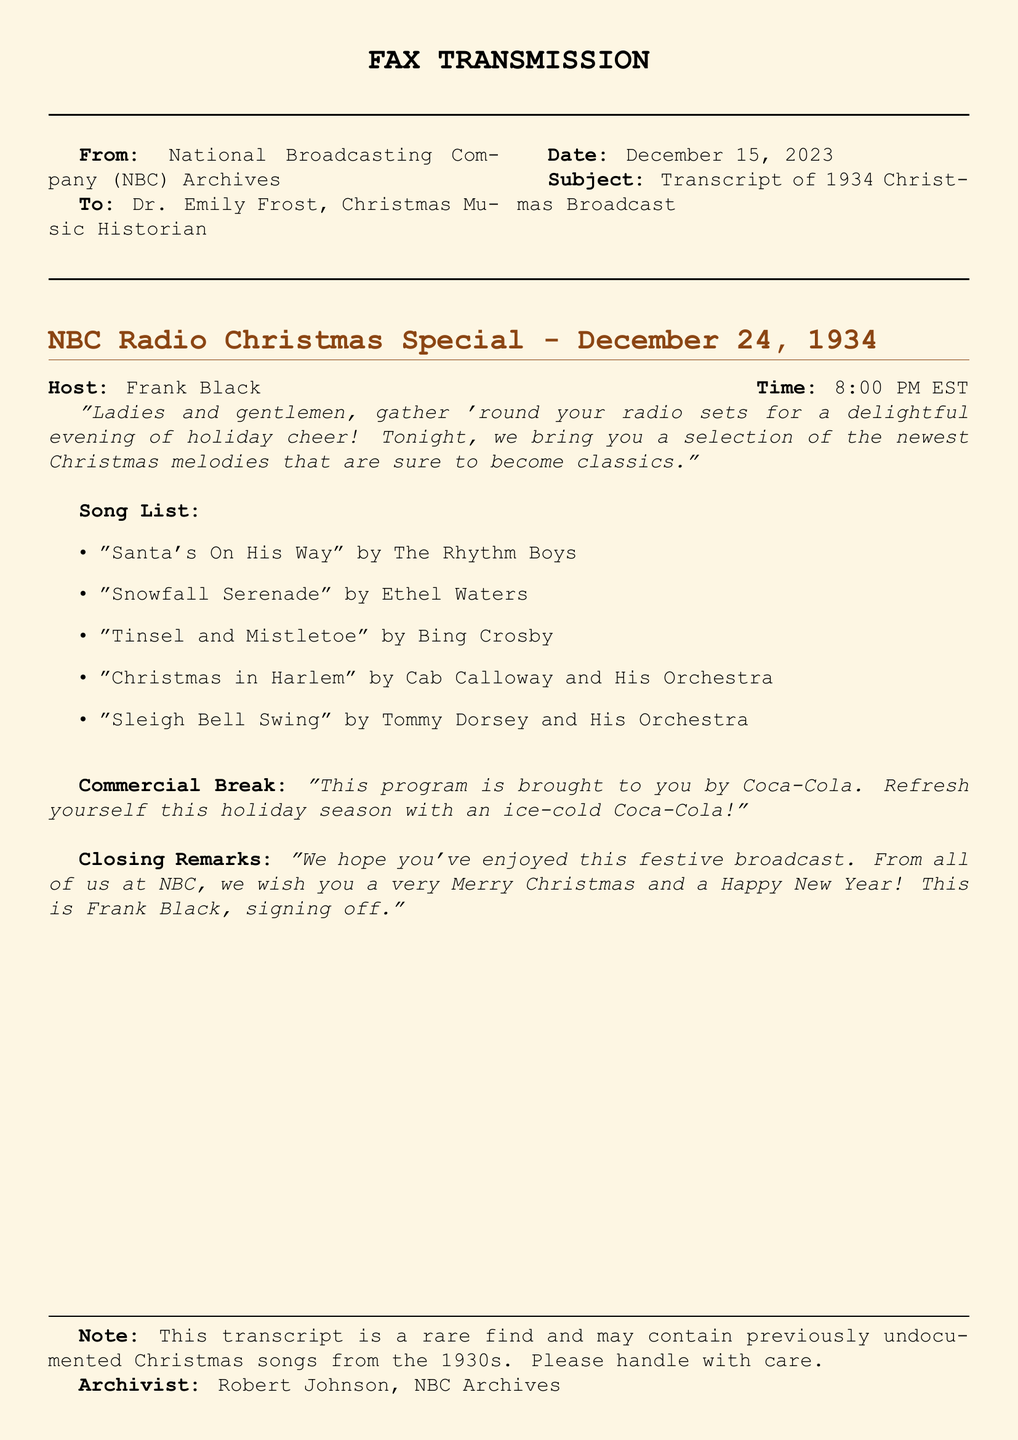What is the date of the broadcast? The broadcast is scheduled for December 24, 1934.
Answer: December 24, 1934 Who hosted the radio special? The host of the radio special is Frank Black.
Answer: Frank Black What is the name of the orchestra that performed "Christmas in Harlem"? The orchestra that performed "Christmas in Harlem" is Cab Calloway and His Orchestra.
Answer: Cab Calloway and His Orchestra How many songs are listed in the broadcast? There are five songs listed in the broadcast.
Answer: Five Who is the archivist mentioned in the document? The archivist mentioned in the document is Robert Johnson.
Answer: Robert Johnson What company sponsored the program? The commercial break mentions that the program is sponsored by Coca-Cola.
Answer: Coca-Cola What is the time of the broadcast in EST? The broadcast is time-stamped at 8:00 PM EST.
Answer: 8:00 PM EST What genre does the song "Sleigh Bell Swing" belong to? The song "Sleigh Bell Swing" is performed by Tommy Dorsey and His Orchestra, suggesting a jazz genre.
Answer: Jazz 